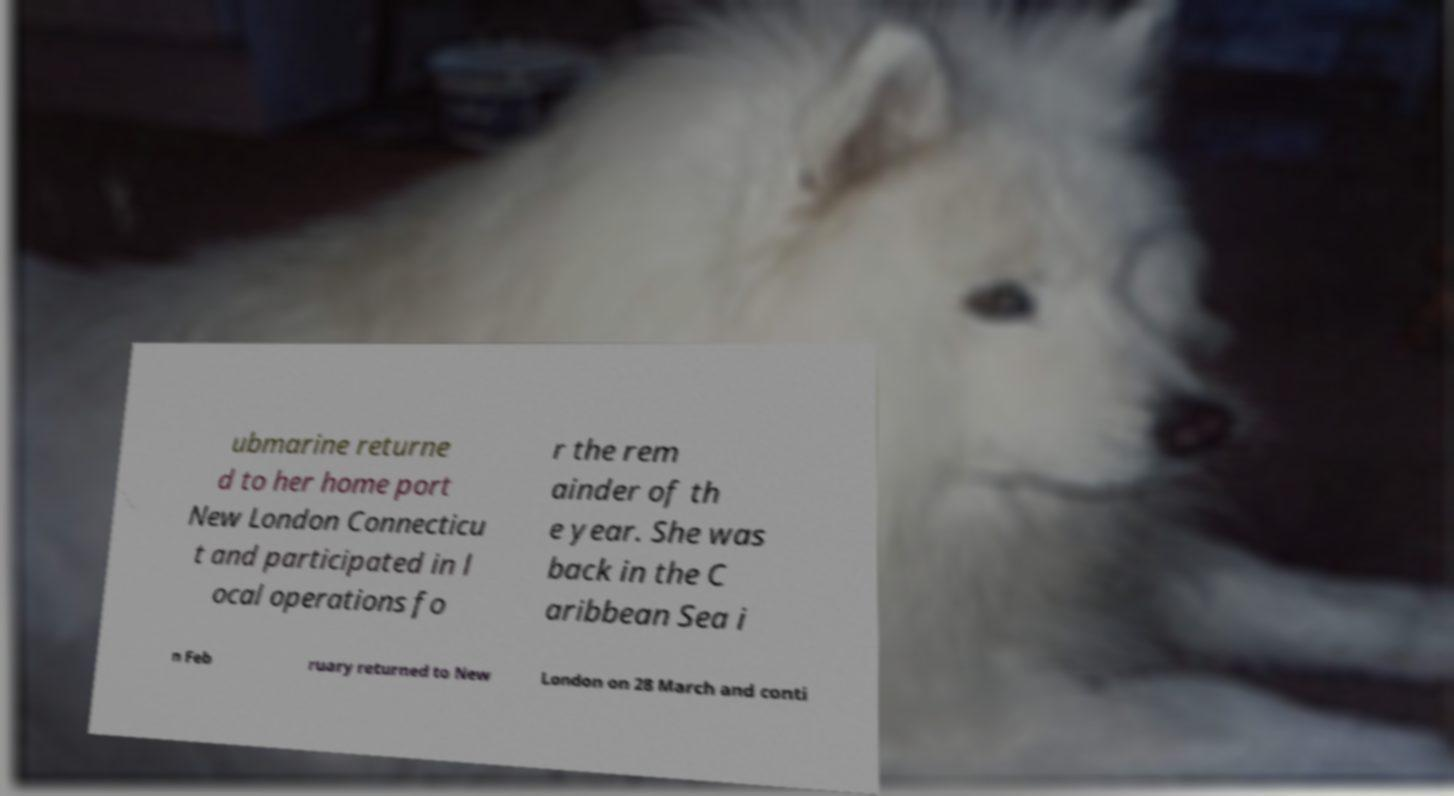Could you extract and type out the text from this image? ubmarine returne d to her home port New London Connecticu t and participated in l ocal operations fo r the rem ainder of th e year. She was back in the C aribbean Sea i n Feb ruary returned to New London on 28 March and conti 